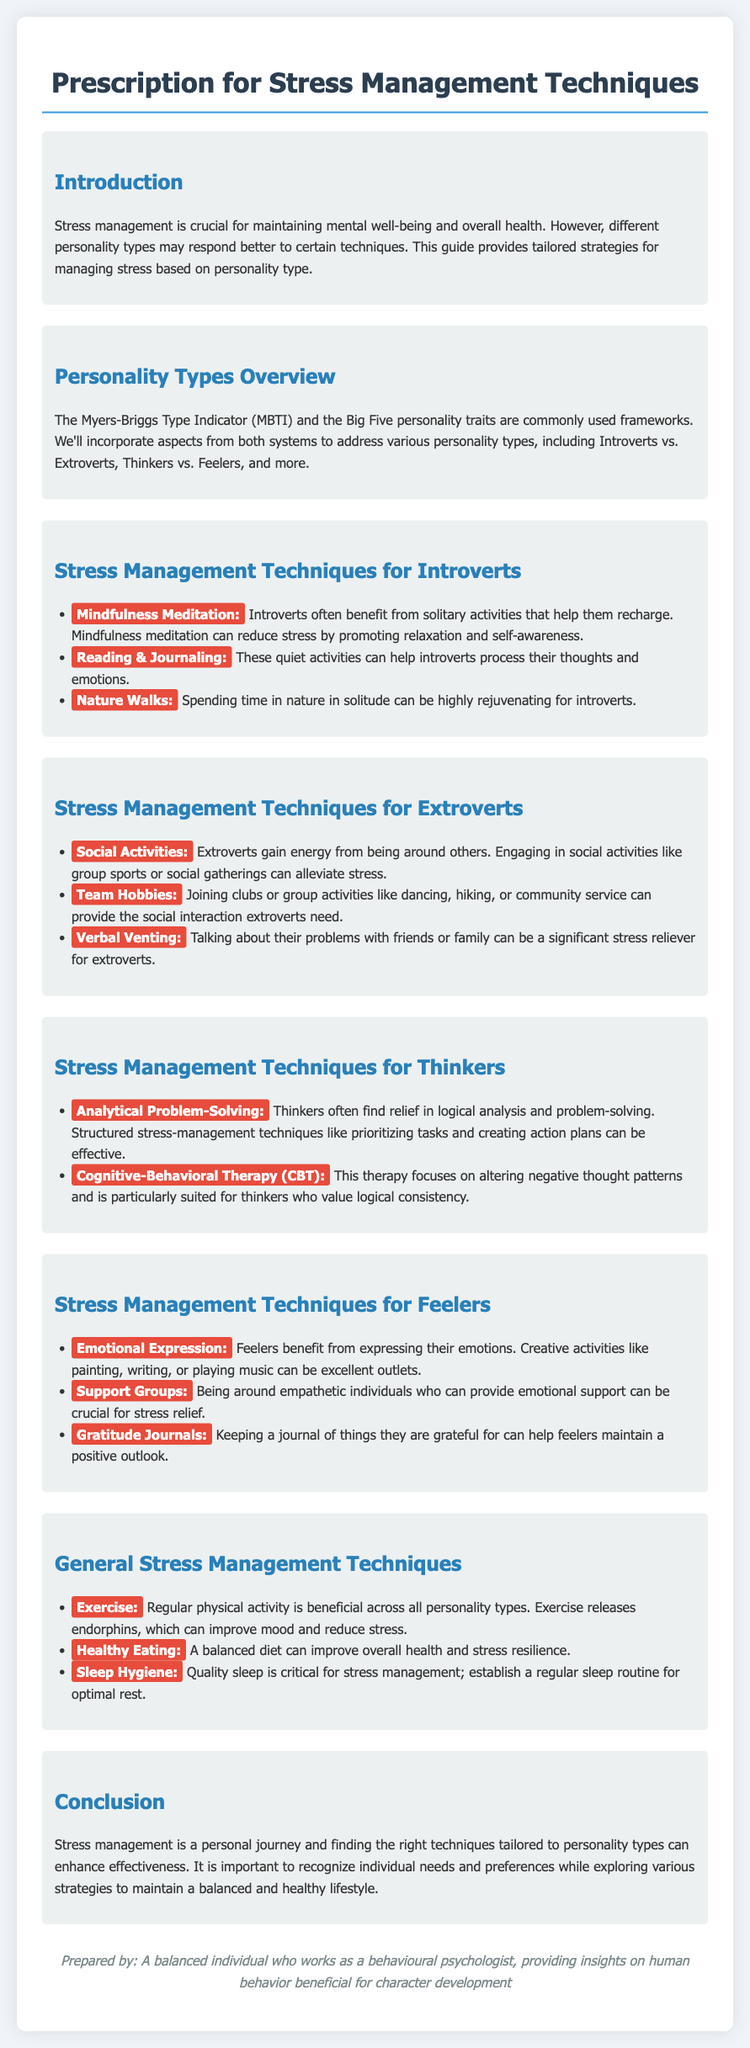What are the personality types mentioned? The document refers to personality types based on the Myers-Briggs Type Indicator (MBTI) and the Big Five personality traits.
Answer: MBTI and Big Five What is a recommended technique for introverts? The document lists several techniques, one of which is mindfulness meditation, specifically beneficial for introverts.
Answer: Mindfulness Meditation How do extroverts alleviate stress? One suggested technique is engaging in social activities, which extroverts find energizing.
Answer: Social Activities What is a stress management technique for thinkers? The document mentions analytical problem-solving as a suitable technique for thinkers.
Answer: Analytical Problem-Solving Name a general stress management technique applicable to all personality types. The document includes exercise as a general technique effective across all personality types.
Answer: Exercise Which activity can help feelers express their emotions? The document states that creative activities like painting are beneficial for feelers.
Answer: Painting How does quality sleep affect stress? The document explains that quality sleep is critical for stress management and suggests establishing a regular sleep routine.
Answer: Critical What is the main purpose of this document? The document aims to provide tailored strategies for managing stress based on personality type.
Answer: Provide tailored strategies What should be maintained to improve stress resilience? Maintaining a balanced diet is highlighted in the document as important for improving stress resilience.
Answer: Balanced Diet 